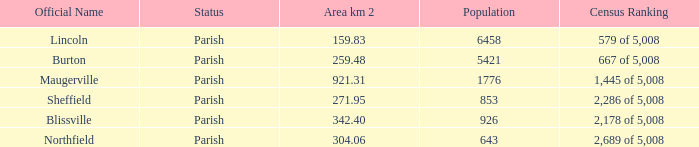What are the formal names of locations that cover an area of 304.06 square kilometers? Northfield. 